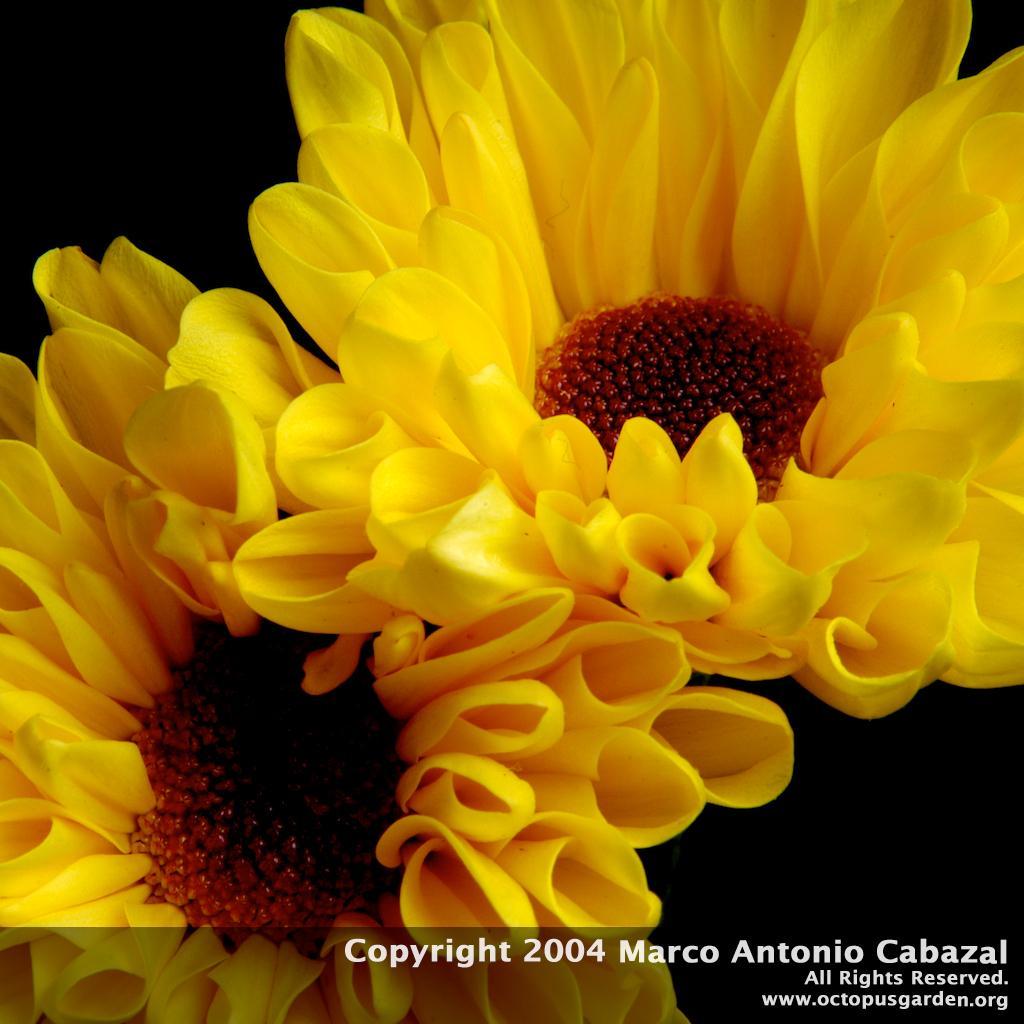Can you describe this image briefly? In this image we can see flowers and at the bottom of the image there is a watermark. In the background it is dark. 